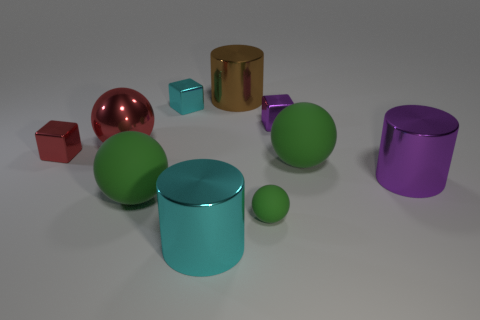Subtract all brown cylinders. How many green balls are left? 3 Subtract all blocks. How many objects are left? 7 Add 4 big cyan metal cylinders. How many big cyan metal cylinders are left? 5 Add 1 small brown cylinders. How many small brown cylinders exist? 1 Subtract 0 yellow blocks. How many objects are left? 10 Subtract all red cubes. Subtract all cylinders. How many objects are left? 6 